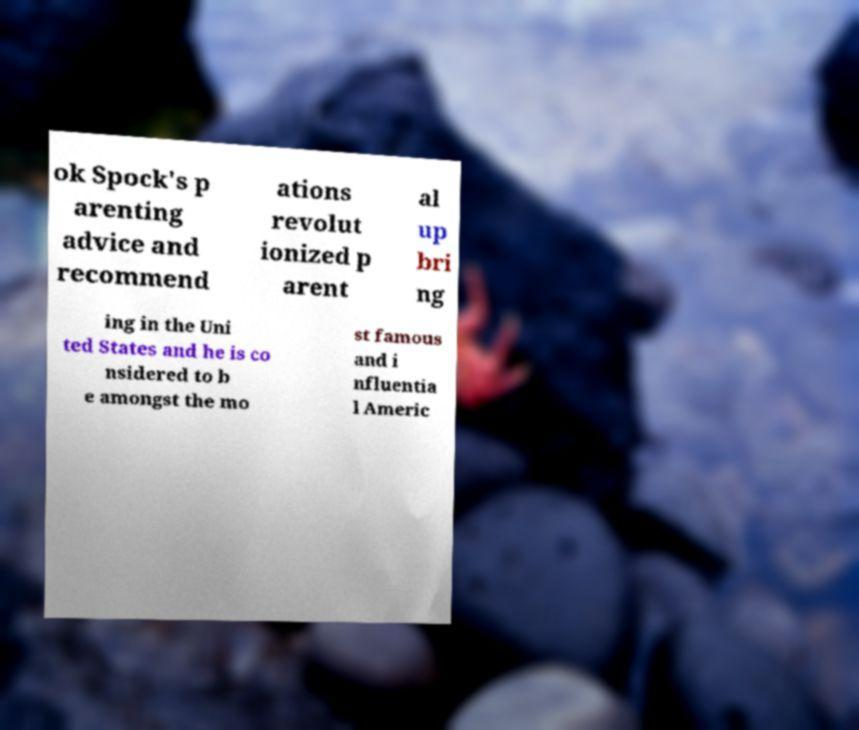For documentation purposes, I need the text within this image transcribed. Could you provide that? ok Spock's p arenting advice and recommend ations revolut ionized p arent al up bri ng ing in the Uni ted States and he is co nsidered to b e amongst the mo st famous and i nfluentia l Americ 